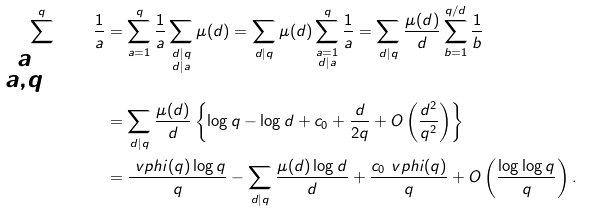Convert formula to latex. <formula><loc_0><loc_0><loc_500><loc_500>\sum _ { \substack { a = 1 \\ ( a , q ) = 1 } } ^ { q } \frac { 1 } { a } & = \sum _ { a = 1 } ^ { q } \frac { 1 } { a } \sum _ { \substack { d | q \\ d | a } } \mu ( d ) = \sum _ { d | q } \mu ( d ) \sum _ { \substack { a = 1 \\ d | a } } ^ { q } \frac { 1 } { a } = \sum _ { d | q } \frac { \mu ( d ) } { d } \sum _ { b = 1 } ^ { q / d } \frac { 1 } { b } \\ & = \sum _ { d | q } \frac { \mu ( d ) } { d } \left \{ \log q - \log d + c _ { 0 } + \frac { d } { 2 q } + O \left ( \frac { d ^ { 2 } } { q ^ { 2 } } \right ) \right \} \\ & = \frac { \ v p h i ( q ) \log q } { q } - \sum _ { d | q } \frac { \mu ( d ) \log d } { d } + \frac { c _ { 0 } \ v p h i ( q ) } { q } + O \left ( \frac { \log \log q } { q } \right ) .</formula> 